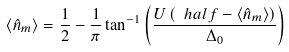Convert formula to latex. <formula><loc_0><loc_0><loc_500><loc_500>\langle \hat { n } _ { m } \rangle = \frac { 1 } { 2 } - \frac { 1 } { \pi } \tan ^ { - 1 } \left ( \frac { U \left ( \ h a l f - \langle \hat { n } _ { m } \rangle \right ) } { \Delta _ { 0 } } \right )</formula> 